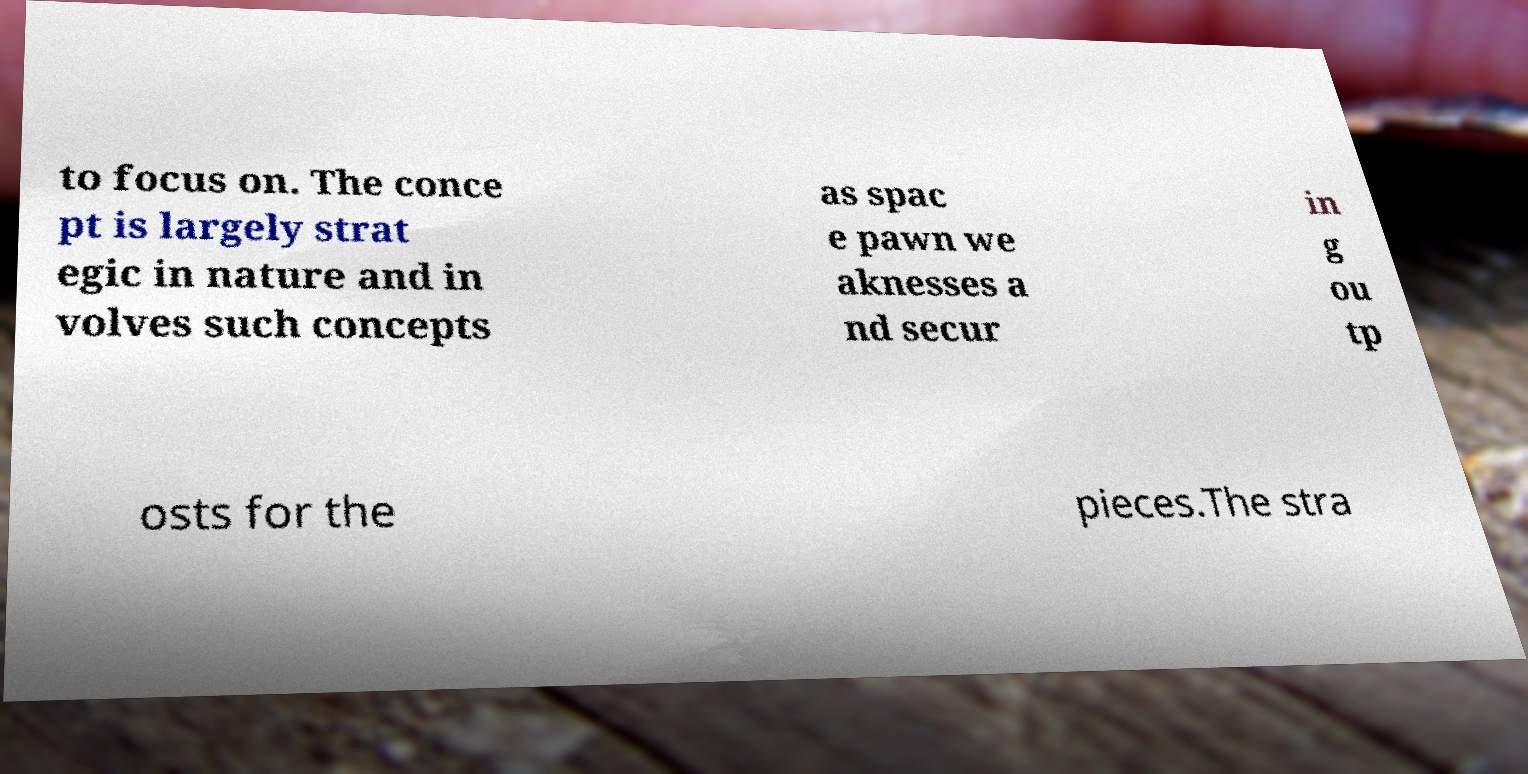I need the written content from this picture converted into text. Can you do that? to focus on. The conce pt is largely strat egic in nature and in volves such concepts as spac e pawn we aknesses a nd secur in g ou tp osts for the pieces.The stra 